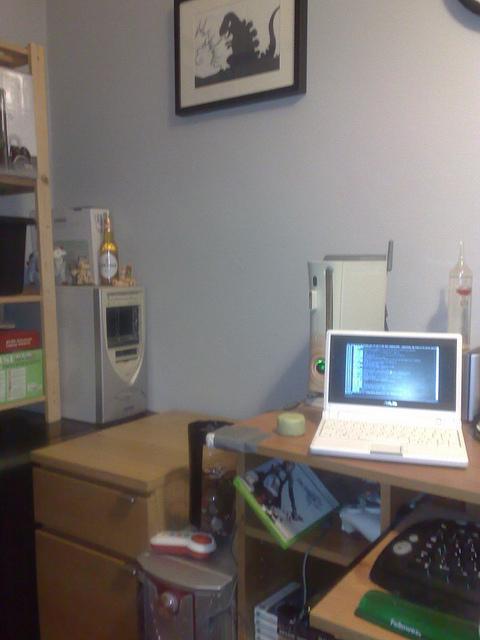What kind of beverage is sat atop of the computer tower in the corner of this room?
Choose the right answer from the provided options to respond to the question.
Options: Water, beer, juice, wine. Beer. 